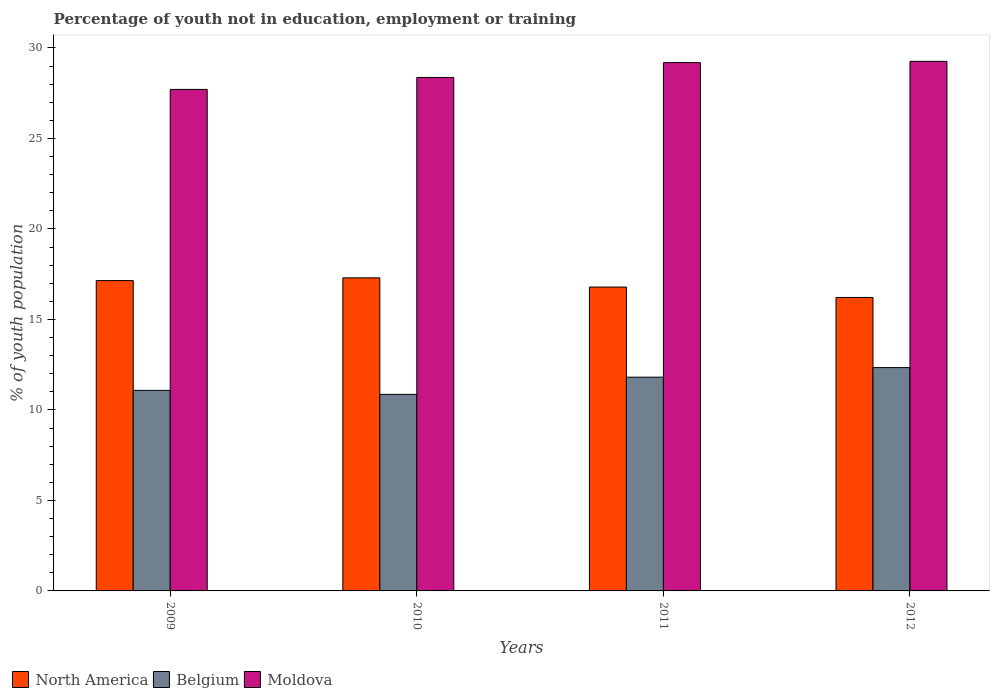How many different coloured bars are there?
Provide a short and direct response. 3. Are the number of bars on each tick of the X-axis equal?
Provide a short and direct response. Yes. What is the label of the 2nd group of bars from the left?
Provide a succinct answer. 2010. What is the percentage of unemployed youth population in in North America in 2011?
Offer a terse response. 16.79. Across all years, what is the maximum percentage of unemployed youth population in in North America?
Your response must be concise. 17.3. Across all years, what is the minimum percentage of unemployed youth population in in Moldova?
Provide a short and direct response. 27.71. What is the total percentage of unemployed youth population in in Moldova in the graph?
Give a very brief answer. 114.53. What is the difference between the percentage of unemployed youth population in in Moldova in 2010 and that in 2012?
Give a very brief answer. -0.89. What is the difference between the percentage of unemployed youth population in in Moldova in 2010 and the percentage of unemployed youth population in in North America in 2009?
Your response must be concise. 11.22. What is the average percentage of unemployed youth population in in North America per year?
Keep it short and to the point. 16.86. In the year 2010, what is the difference between the percentage of unemployed youth population in in Belgium and percentage of unemployed youth population in in North America?
Your answer should be compact. -6.44. In how many years, is the percentage of unemployed youth population in in Moldova greater than 28 %?
Ensure brevity in your answer.  3. What is the ratio of the percentage of unemployed youth population in in Moldova in 2011 to that in 2012?
Keep it short and to the point. 1. Is the percentage of unemployed youth population in in North America in 2010 less than that in 2012?
Provide a succinct answer. No. Is the difference between the percentage of unemployed youth population in in Belgium in 2011 and 2012 greater than the difference between the percentage of unemployed youth population in in North America in 2011 and 2012?
Provide a succinct answer. No. What is the difference between the highest and the second highest percentage of unemployed youth population in in Belgium?
Offer a terse response. 0.53. What is the difference between the highest and the lowest percentage of unemployed youth population in in North America?
Offer a terse response. 1.09. In how many years, is the percentage of unemployed youth population in in Belgium greater than the average percentage of unemployed youth population in in Belgium taken over all years?
Make the answer very short. 2. Is the sum of the percentage of unemployed youth population in in Belgium in 2010 and 2011 greater than the maximum percentage of unemployed youth population in in North America across all years?
Offer a very short reply. Yes. How many years are there in the graph?
Your response must be concise. 4. Are the values on the major ticks of Y-axis written in scientific E-notation?
Give a very brief answer. No. Does the graph contain grids?
Offer a terse response. No. Where does the legend appear in the graph?
Keep it short and to the point. Bottom left. How are the legend labels stacked?
Offer a very short reply. Horizontal. What is the title of the graph?
Provide a succinct answer. Percentage of youth not in education, employment or training. What is the label or title of the X-axis?
Keep it short and to the point. Years. What is the label or title of the Y-axis?
Your answer should be compact. % of youth population. What is the % of youth population of North America in 2009?
Provide a succinct answer. 17.15. What is the % of youth population of Belgium in 2009?
Provide a short and direct response. 11.08. What is the % of youth population of Moldova in 2009?
Offer a terse response. 27.71. What is the % of youth population of North America in 2010?
Offer a very short reply. 17.3. What is the % of youth population of Belgium in 2010?
Your answer should be very brief. 10.86. What is the % of youth population in Moldova in 2010?
Provide a succinct answer. 28.37. What is the % of youth population of North America in 2011?
Provide a succinct answer. 16.79. What is the % of youth population in Belgium in 2011?
Ensure brevity in your answer.  11.81. What is the % of youth population of Moldova in 2011?
Ensure brevity in your answer.  29.19. What is the % of youth population of North America in 2012?
Keep it short and to the point. 16.21. What is the % of youth population of Belgium in 2012?
Give a very brief answer. 12.34. What is the % of youth population in Moldova in 2012?
Provide a succinct answer. 29.26. Across all years, what is the maximum % of youth population in North America?
Keep it short and to the point. 17.3. Across all years, what is the maximum % of youth population of Belgium?
Offer a very short reply. 12.34. Across all years, what is the maximum % of youth population in Moldova?
Provide a short and direct response. 29.26. Across all years, what is the minimum % of youth population of North America?
Give a very brief answer. 16.21. Across all years, what is the minimum % of youth population of Belgium?
Your response must be concise. 10.86. Across all years, what is the minimum % of youth population in Moldova?
Give a very brief answer. 27.71. What is the total % of youth population in North America in the graph?
Your answer should be very brief. 67.45. What is the total % of youth population in Belgium in the graph?
Offer a terse response. 46.09. What is the total % of youth population of Moldova in the graph?
Provide a succinct answer. 114.53. What is the difference between the % of youth population of North America in 2009 and that in 2010?
Keep it short and to the point. -0.15. What is the difference between the % of youth population in Belgium in 2009 and that in 2010?
Provide a short and direct response. 0.22. What is the difference between the % of youth population of Moldova in 2009 and that in 2010?
Give a very brief answer. -0.66. What is the difference between the % of youth population in North America in 2009 and that in 2011?
Make the answer very short. 0.36. What is the difference between the % of youth population of Belgium in 2009 and that in 2011?
Offer a very short reply. -0.73. What is the difference between the % of youth population in Moldova in 2009 and that in 2011?
Give a very brief answer. -1.48. What is the difference between the % of youth population in North America in 2009 and that in 2012?
Keep it short and to the point. 0.93. What is the difference between the % of youth population in Belgium in 2009 and that in 2012?
Your response must be concise. -1.26. What is the difference between the % of youth population of Moldova in 2009 and that in 2012?
Keep it short and to the point. -1.55. What is the difference between the % of youth population in North America in 2010 and that in 2011?
Make the answer very short. 0.51. What is the difference between the % of youth population in Belgium in 2010 and that in 2011?
Your answer should be very brief. -0.95. What is the difference between the % of youth population of Moldova in 2010 and that in 2011?
Provide a short and direct response. -0.82. What is the difference between the % of youth population in North America in 2010 and that in 2012?
Ensure brevity in your answer.  1.08. What is the difference between the % of youth population in Belgium in 2010 and that in 2012?
Offer a terse response. -1.48. What is the difference between the % of youth population in Moldova in 2010 and that in 2012?
Your answer should be very brief. -0.89. What is the difference between the % of youth population in North America in 2011 and that in 2012?
Your answer should be very brief. 0.58. What is the difference between the % of youth population in Belgium in 2011 and that in 2012?
Your answer should be very brief. -0.53. What is the difference between the % of youth population in Moldova in 2011 and that in 2012?
Keep it short and to the point. -0.07. What is the difference between the % of youth population in North America in 2009 and the % of youth population in Belgium in 2010?
Provide a succinct answer. 6.29. What is the difference between the % of youth population of North America in 2009 and the % of youth population of Moldova in 2010?
Keep it short and to the point. -11.22. What is the difference between the % of youth population of Belgium in 2009 and the % of youth population of Moldova in 2010?
Provide a succinct answer. -17.29. What is the difference between the % of youth population in North America in 2009 and the % of youth population in Belgium in 2011?
Make the answer very short. 5.34. What is the difference between the % of youth population of North America in 2009 and the % of youth population of Moldova in 2011?
Your answer should be compact. -12.04. What is the difference between the % of youth population in Belgium in 2009 and the % of youth population in Moldova in 2011?
Your answer should be very brief. -18.11. What is the difference between the % of youth population in North America in 2009 and the % of youth population in Belgium in 2012?
Ensure brevity in your answer.  4.81. What is the difference between the % of youth population in North America in 2009 and the % of youth population in Moldova in 2012?
Make the answer very short. -12.11. What is the difference between the % of youth population in Belgium in 2009 and the % of youth population in Moldova in 2012?
Your response must be concise. -18.18. What is the difference between the % of youth population in North America in 2010 and the % of youth population in Belgium in 2011?
Offer a very short reply. 5.49. What is the difference between the % of youth population of North America in 2010 and the % of youth population of Moldova in 2011?
Your response must be concise. -11.89. What is the difference between the % of youth population of Belgium in 2010 and the % of youth population of Moldova in 2011?
Keep it short and to the point. -18.33. What is the difference between the % of youth population of North America in 2010 and the % of youth population of Belgium in 2012?
Your answer should be compact. 4.96. What is the difference between the % of youth population in North America in 2010 and the % of youth population in Moldova in 2012?
Ensure brevity in your answer.  -11.96. What is the difference between the % of youth population in Belgium in 2010 and the % of youth population in Moldova in 2012?
Make the answer very short. -18.4. What is the difference between the % of youth population of North America in 2011 and the % of youth population of Belgium in 2012?
Ensure brevity in your answer.  4.45. What is the difference between the % of youth population in North America in 2011 and the % of youth population in Moldova in 2012?
Ensure brevity in your answer.  -12.47. What is the difference between the % of youth population in Belgium in 2011 and the % of youth population in Moldova in 2012?
Your answer should be very brief. -17.45. What is the average % of youth population of North America per year?
Provide a succinct answer. 16.86. What is the average % of youth population in Belgium per year?
Your answer should be compact. 11.52. What is the average % of youth population in Moldova per year?
Give a very brief answer. 28.63. In the year 2009, what is the difference between the % of youth population of North America and % of youth population of Belgium?
Offer a terse response. 6.07. In the year 2009, what is the difference between the % of youth population of North America and % of youth population of Moldova?
Keep it short and to the point. -10.56. In the year 2009, what is the difference between the % of youth population in Belgium and % of youth population in Moldova?
Make the answer very short. -16.63. In the year 2010, what is the difference between the % of youth population of North America and % of youth population of Belgium?
Your answer should be compact. 6.44. In the year 2010, what is the difference between the % of youth population in North America and % of youth population in Moldova?
Provide a short and direct response. -11.07. In the year 2010, what is the difference between the % of youth population of Belgium and % of youth population of Moldova?
Provide a short and direct response. -17.51. In the year 2011, what is the difference between the % of youth population in North America and % of youth population in Belgium?
Your answer should be very brief. 4.98. In the year 2011, what is the difference between the % of youth population in North America and % of youth population in Moldova?
Give a very brief answer. -12.4. In the year 2011, what is the difference between the % of youth population of Belgium and % of youth population of Moldova?
Your response must be concise. -17.38. In the year 2012, what is the difference between the % of youth population in North America and % of youth population in Belgium?
Ensure brevity in your answer.  3.87. In the year 2012, what is the difference between the % of youth population in North America and % of youth population in Moldova?
Provide a succinct answer. -13.05. In the year 2012, what is the difference between the % of youth population of Belgium and % of youth population of Moldova?
Your answer should be compact. -16.92. What is the ratio of the % of youth population in North America in 2009 to that in 2010?
Provide a succinct answer. 0.99. What is the ratio of the % of youth population of Belgium in 2009 to that in 2010?
Offer a very short reply. 1.02. What is the ratio of the % of youth population of Moldova in 2009 to that in 2010?
Offer a terse response. 0.98. What is the ratio of the % of youth population of North America in 2009 to that in 2011?
Your answer should be very brief. 1.02. What is the ratio of the % of youth population in Belgium in 2009 to that in 2011?
Your response must be concise. 0.94. What is the ratio of the % of youth population of Moldova in 2009 to that in 2011?
Your answer should be very brief. 0.95. What is the ratio of the % of youth population in North America in 2009 to that in 2012?
Ensure brevity in your answer.  1.06. What is the ratio of the % of youth population in Belgium in 2009 to that in 2012?
Ensure brevity in your answer.  0.9. What is the ratio of the % of youth population of Moldova in 2009 to that in 2012?
Ensure brevity in your answer.  0.95. What is the ratio of the % of youth population of North America in 2010 to that in 2011?
Offer a very short reply. 1.03. What is the ratio of the % of youth population in Belgium in 2010 to that in 2011?
Your answer should be very brief. 0.92. What is the ratio of the % of youth population of Moldova in 2010 to that in 2011?
Offer a terse response. 0.97. What is the ratio of the % of youth population of North America in 2010 to that in 2012?
Make the answer very short. 1.07. What is the ratio of the % of youth population of Belgium in 2010 to that in 2012?
Give a very brief answer. 0.88. What is the ratio of the % of youth population in Moldova in 2010 to that in 2012?
Give a very brief answer. 0.97. What is the ratio of the % of youth population in North America in 2011 to that in 2012?
Offer a very short reply. 1.04. What is the ratio of the % of youth population in Belgium in 2011 to that in 2012?
Provide a short and direct response. 0.96. What is the ratio of the % of youth population of Moldova in 2011 to that in 2012?
Your answer should be compact. 1. What is the difference between the highest and the second highest % of youth population in North America?
Offer a very short reply. 0.15. What is the difference between the highest and the second highest % of youth population in Belgium?
Offer a very short reply. 0.53. What is the difference between the highest and the second highest % of youth population of Moldova?
Offer a very short reply. 0.07. What is the difference between the highest and the lowest % of youth population of North America?
Offer a terse response. 1.08. What is the difference between the highest and the lowest % of youth population of Belgium?
Make the answer very short. 1.48. What is the difference between the highest and the lowest % of youth population of Moldova?
Your response must be concise. 1.55. 